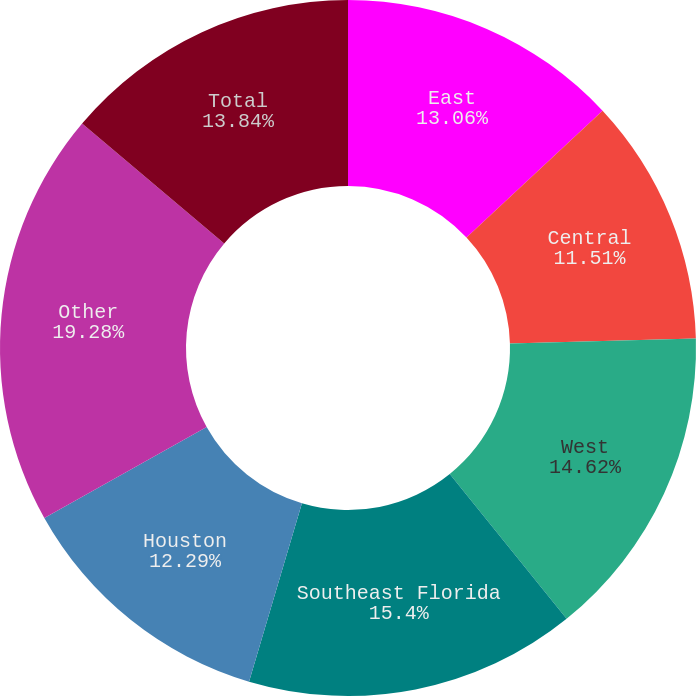Convert chart to OTSL. <chart><loc_0><loc_0><loc_500><loc_500><pie_chart><fcel>East<fcel>Central<fcel>West<fcel>Southeast Florida<fcel>Houston<fcel>Other<fcel>Total<nl><fcel>13.06%<fcel>11.51%<fcel>14.62%<fcel>15.4%<fcel>12.29%<fcel>19.28%<fcel>13.84%<nl></chart> 